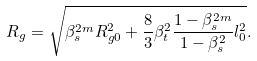Convert formula to latex. <formula><loc_0><loc_0><loc_500><loc_500>R _ { g } = \sqrt { \beta _ { s } ^ { 2 m } R _ { g 0 } ^ { 2 } + \frac { 8 } { 3 } \beta _ { t } ^ { 2 } \frac { 1 - \beta _ { s } ^ { 2 m } } { 1 - \beta _ { s } ^ { 2 } } l _ { 0 } ^ { 2 } } .</formula> 